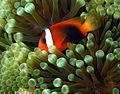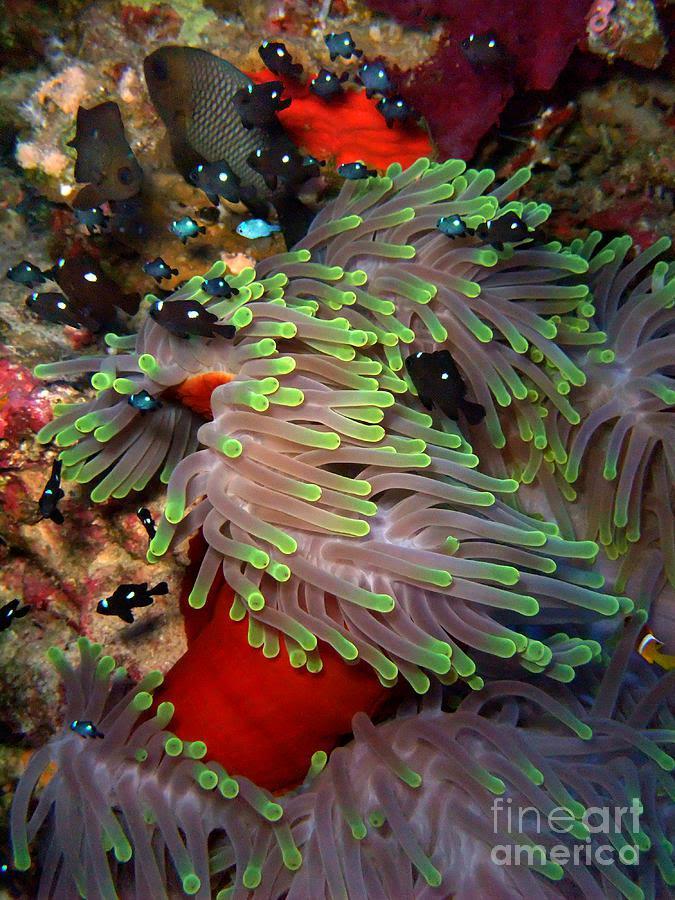The first image is the image on the left, the second image is the image on the right. Evaluate the accuracy of this statement regarding the images: "At least one fish is orange.". Is it true? Answer yes or no. Yes. The first image is the image on the left, the second image is the image on the right. Evaluate the accuracy of this statement regarding the images: "The left and right image contains the same number of fish.". Is it true? Answer yes or no. No. 